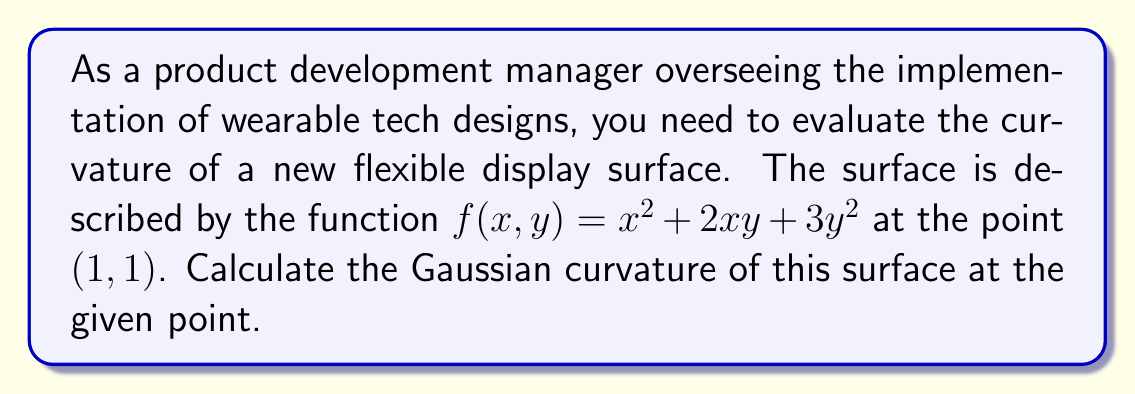Give your solution to this math problem. To calculate the Gaussian curvature of a surface described by $z = f(x,y)$ at a point $(x_0, y_0)$, we use the following formula:

$$ K = \frac{f_{xx}f_{yy} - f_{xy}^2}{(1 + f_x^2 + f_y^2)^2} $$

Where $f_{xx}, f_{yy},$ and $f_{xy}$ are the second partial derivatives, and $f_x$ and $f_y$ are the first partial derivatives, all evaluated at the point $(x_0, y_0)$.

Step 1: Calculate the first partial derivatives:
$f_x = 2x + 2y$
$f_y = 2x + 6y$

Step 2: Calculate the second partial derivatives:
$f_{xx} = 2$
$f_{yy} = 6$
$f_{xy} = 2$

Step 3: Evaluate the derivatives at the point (1,1):
$f_x(1,1) = 2(1) + 2(1) = 4$
$f_y(1,1) = 2(1) + 6(1) = 8$
$f_{xx}(1,1) = 2$
$f_{yy}(1,1) = 6$
$f_{xy}(1,1) = 2$

Step 4: Apply the Gaussian curvature formula:

$$ K = \frac{f_{xx}f_{yy} - f_{xy}^2}{(1 + f_x^2 + f_y^2)^2} $$

$$ K = \frac{(2)(6) - (2)^2}{(1 + 4^2 + 8^2)^2} $$

$$ K = \frac{12 - 4}{(1 + 16 + 64)^2} = \frac{8}{81^2} = \frac{8}{6561} $$
Answer: The Gaussian curvature of the flexible display surface at the point (1,1) is $\frac{8}{6561} \approx 0.00122$. 